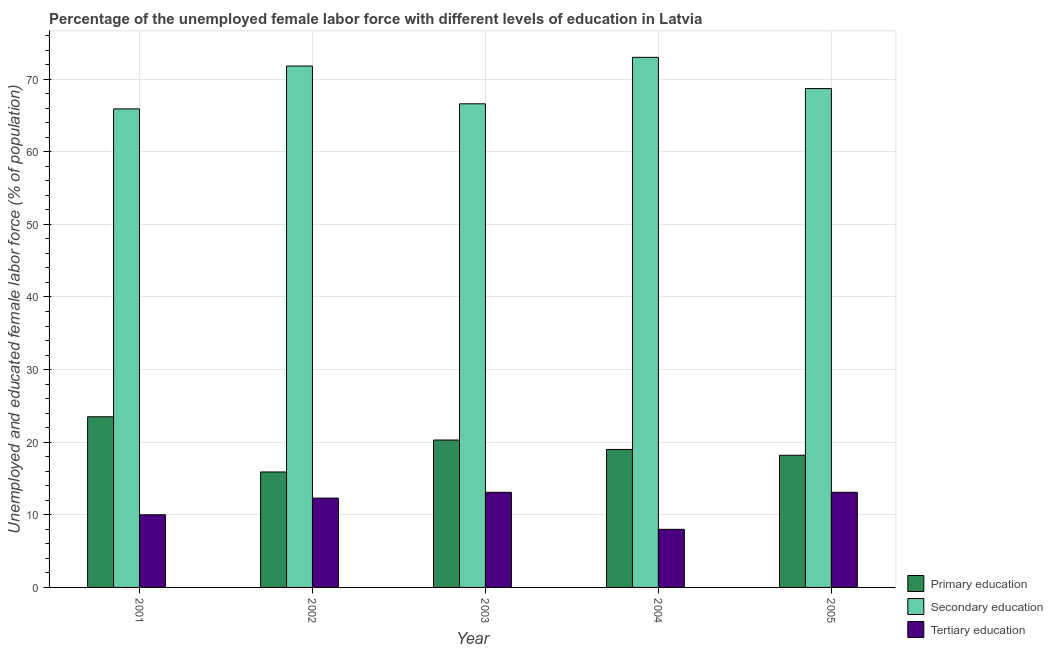How many different coloured bars are there?
Ensure brevity in your answer.  3. Are the number of bars on each tick of the X-axis equal?
Your answer should be compact. Yes. How many bars are there on the 2nd tick from the left?
Give a very brief answer. 3. How many bars are there on the 5th tick from the right?
Your answer should be very brief. 3. What is the percentage of female labor force who received tertiary education in 2001?
Give a very brief answer. 10. Across all years, what is the maximum percentage of female labor force who received primary education?
Offer a very short reply. 23.5. Across all years, what is the minimum percentage of female labor force who received secondary education?
Provide a short and direct response. 65.9. In which year was the percentage of female labor force who received tertiary education minimum?
Offer a terse response. 2004. What is the total percentage of female labor force who received primary education in the graph?
Make the answer very short. 96.9. What is the difference between the percentage of female labor force who received primary education in 2003 and that in 2004?
Provide a short and direct response. 1.3. What is the difference between the percentage of female labor force who received primary education in 2001 and the percentage of female labor force who received tertiary education in 2004?
Your answer should be compact. 4.5. What is the average percentage of female labor force who received tertiary education per year?
Provide a short and direct response. 11.3. In how many years, is the percentage of female labor force who received primary education greater than 54 %?
Ensure brevity in your answer.  0. What is the ratio of the percentage of female labor force who received tertiary education in 2003 to that in 2004?
Offer a very short reply. 1.64. Is the percentage of female labor force who received primary education in 2001 less than that in 2003?
Provide a succinct answer. No. Is the difference between the percentage of female labor force who received primary education in 2001 and 2005 greater than the difference between the percentage of female labor force who received secondary education in 2001 and 2005?
Give a very brief answer. No. What is the difference between the highest and the second highest percentage of female labor force who received primary education?
Give a very brief answer. 3.2. What is the difference between the highest and the lowest percentage of female labor force who received secondary education?
Your answer should be very brief. 7.1. Is the sum of the percentage of female labor force who received primary education in 2001 and 2003 greater than the maximum percentage of female labor force who received tertiary education across all years?
Offer a terse response. Yes. What does the 3rd bar from the left in 2003 represents?
Provide a short and direct response. Tertiary education. What does the 1st bar from the right in 2003 represents?
Your answer should be very brief. Tertiary education. Is it the case that in every year, the sum of the percentage of female labor force who received primary education and percentage of female labor force who received secondary education is greater than the percentage of female labor force who received tertiary education?
Give a very brief answer. Yes. How many bars are there?
Ensure brevity in your answer.  15. Are all the bars in the graph horizontal?
Your answer should be very brief. No. Are the values on the major ticks of Y-axis written in scientific E-notation?
Make the answer very short. No. Does the graph contain grids?
Ensure brevity in your answer.  Yes. Where does the legend appear in the graph?
Your answer should be compact. Bottom right. How many legend labels are there?
Your response must be concise. 3. What is the title of the graph?
Make the answer very short. Percentage of the unemployed female labor force with different levels of education in Latvia. Does "Ores and metals" appear as one of the legend labels in the graph?
Provide a short and direct response. No. What is the label or title of the Y-axis?
Make the answer very short. Unemployed and educated female labor force (% of population). What is the Unemployed and educated female labor force (% of population) in Primary education in 2001?
Your response must be concise. 23.5. What is the Unemployed and educated female labor force (% of population) in Secondary education in 2001?
Offer a terse response. 65.9. What is the Unemployed and educated female labor force (% of population) of Tertiary education in 2001?
Make the answer very short. 10. What is the Unemployed and educated female labor force (% of population) in Primary education in 2002?
Make the answer very short. 15.9. What is the Unemployed and educated female labor force (% of population) in Secondary education in 2002?
Offer a terse response. 71.8. What is the Unemployed and educated female labor force (% of population) in Tertiary education in 2002?
Give a very brief answer. 12.3. What is the Unemployed and educated female labor force (% of population) in Primary education in 2003?
Offer a very short reply. 20.3. What is the Unemployed and educated female labor force (% of population) in Secondary education in 2003?
Provide a short and direct response. 66.6. What is the Unemployed and educated female labor force (% of population) of Tertiary education in 2003?
Provide a short and direct response. 13.1. What is the Unemployed and educated female labor force (% of population) in Primary education in 2004?
Make the answer very short. 19. What is the Unemployed and educated female labor force (% of population) of Primary education in 2005?
Provide a succinct answer. 18.2. What is the Unemployed and educated female labor force (% of population) in Secondary education in 2005?
Ensure brevity in your answer.  68.7. What is the Unemployed and educated female labor force (% of population) in Tertiary education in 2005?
Offer a very short reply. 13.1. Across all years, what is the maximum Unemployed and educated female labor force (% of population) in Secondary education?
Make the answer very short. 73. Across all years, what is the maximum Unemployed and educated female labor force (% of population) of Tertiary education?
Ensure brevity in your answer.  13.1. Across all years, what is the minimum Unemployed and educated female labor force (% of population) of Primary education?
Ensure brevity in your answer.  15.9. Across all years, what is the minimum Unemployed and educated female labor force (% of population) in Secondary education?
Make the answer very short. 65.9. What is the total Unemployed and educated female labor force (% of population) of Primary education in the graph?
Provide a short and direct response. 96.9. What is the total Unemployed and educated female labor force (% of population) of Secondary education in the graph?
Offer a very short reply. 346. What is the total Unemployed and educated female labor force (% of population) in Tertiary education in the graph?
Keep it short and to the point. 56.5. What is the difference between the Unemployed and educated female labor force (% of population) of Primary education in 2001 and that in 2002?
Your answer should be compact. 7.6. What is the difference between the Unemployed and educated female labor force (% of population) in Primary education in 2001 and that in 2003?
Provide a succinct answer. 3.2. What is the difference between the Unemployed and educated female labor force (% of population) of Secondary education in 2001 and that in 2003?
Your answer should be compact. -0.7. What is the difference between the Unemployed and educated female labor force (% of population) in Tertiary education in 2001 and that in 2003?
Provide a succinct answer. -3.1. What is the difference between the Unemployed and educated female labor force (% of population) of Primary education in 2001 and that in 2004?
Provide a succinct answer. 4.5. What is the difference between the Unemployed and educated female labor force (% of population) of Secondary education in 2001 and that in 2004?
Offer a terse response. -7.1. What is the difference between the Unemployed and educated female labor force (% of population) in Tertiary education in 2001 and that in 2004?
Offer a very short reply. 2. What is the difference between the Unemployed and educated female labor force (% of population) in Secondary education in 2001 and that in 2005?
Keep it short and to the point. -2.8. What is the difference between the Unemployed and educated female labor force (% of population) in Primary education in 2002 and that in 2004?
Your response must be concise. -3.1. What is the difference between the Unemployed and educated female labor force (% of population) in Secondary education in 2002 and that in 2004?
Your response must be concise. -1.2. What is the difference between the Unemployed and educated female labor force (% of population) in Tertiary education in 2002 and that in 2004?
Give a very brief answer. 4.3. What is the difference between the Unemployed and educated female labor force (% of population) of Primary education in 2002 and that in 2005?
Your answer should be compact. -2.3. What is the difference between the Unemployed and educated female labor force (% of population) in Secondary education in 2002 and that in 2005?
Keep it short and to the point. 3.1. What is the difference between the Unemployed and educated female labor force (% of population) of Primary education in 2003 and that in 2004?
Make the answer very short. 1.3. What is the difference between the Unemployed and educated female labor force (% of population) in Secondary education in 2003 and that in 2004?
Your answer should be very brief. -6.4. What is the difference between the Unemployed and educated female labor force (% of population) in Primary education in 2003 and that in 2005?
Provide a short and direct response. 2.1. What is the difference between the Unemployed and educated female labor force (% of population) of Secondary education in 2003 and that in 2005?
Offer a very short reply. -2.1. What is the difference between the Unemployed and educated female labor force (% of population) in Tertiary education in 2003 and that in 2005?
Offer a terse response. 0. What is the difference between the Unemployed and educated female labor force (% of population) of Primary education in 2004 and that in 2005?
Your response must be concise. 0.8. What is the difference between the Unemployed and educated female labor force (% of population) of Secondary education in 2004 and that in 2005?
Give a very brief answer. 4.3. What is the difference between the Unemployed and educated female labor force (% of population) in Tertiary education in 2004 and that in 2005?
Make the answer very short. -5.1. What is the difference between the Unemployed and educated female labor force (% of population) of Primary education in 2001 and the Unemployed and educated female labor force (% of population) of Secondary education in 2002?
Your response must be concise. -48.3. What is the difference between the Unemployed and educated female labor force (% of population) of Secondary education in 2001 and the Unemployed and educated female labor force (% of population) of Tertiary education in 2002?
Offer a terse response. 53.6. What is the difference between the Unemployed and educated female labor force (% of population) in Primary education in 2001 and the Unemployed and educated female labor force (% of population) in Secondary education in 2003?
Make the answer very short. -43.1. What is the difference between the Unemployed and educated female labor force (% of population) in Secondary education in 2001 and the Unemployed and educated female labor force (% of population) in Tertiary education in 2003?
Keep it short and to the point. 52.8. What is the difference between the Unemployed and educated female labor force (% of population) of Primary education in 2001 and the Unemployed and educated female labor force (% of population) of Secondary education in 2004?
Offer a very short reply. -49.5. What is the difference between the Unemployed and educated female labor force (% of population) in Secondary education in 2001 and the Unemployed and educated female labor force (% of population) in Tertiary education in 2004?
Offer a terse response. 57.9. What is the difference between the Unemployed and educated female labor force (% of population) of Primary education in 2001 and the Unemployed and educated female labor force (% of population) of Secondary education in 2005?
Provide a short and direct response. -45.2. What is the difference between the Unemployed and educated female labor force (% of population) in Secondary education in 2001 and the Unemployed and educated female labor force (% of population) in Tertiary education in 2005?
Offer a very short reply. 52.8. What is the difference between the Unemployed and educated female labor force (% of population) of Primary education in 2002 and the Unemployed and educated female labor force (% of population) of Secondary education in 2003?
Give a very brief answer. -50.7. What is the difference between the Unemployed and educated female labor force (% of population) of Primary education in 2002 and the Unemployed and educated female labor force (% of population) of Tertiary education in 2003?
Give a very brief answer. 2.8. What is the difference between the Unemployed and educated female labor force (% of population) of Secondary education in 2002 and the Unemployed and educated female labor force (% of population) of Tertiary education in 2003?
Your answer should be very brief. 58.7. What is the difference between the Unemployed and educated female labor force (% of population) of Primary education in 2002 and the Unemployed and educated female labor force (% of population) of Secondary education in 2004?
Keep it short and to the point. -57.1. What is the difference between the Unemployed and educated female labor force (% of population) of Secondary education in 2002 and the Unemployed and educated female labor force (% of population) of Tertiary education in 2004?
Give a very brief answer. 63.8. What is the difference between the Unemployed and educated female labor force (% of population) of Primary education in 2002 and the Unemployed and educated female labor force (% of population) of Secondary education in 2005?
Make the answer very short. -52.8. What is the difference between the Unemployed and educated female labor force (% of population) in Primary education in 2002 and the Unemployed and educated female labor force (% of population) in Tertiary education in 2005?
Your response must be concise. 2.8. What is the difference between the Unemployed and educated female labor force (% of population) of Secondary education in 2002 and the Unemployed and educated female labor force (% of population) of Tertiary education in 2005?
Ensure brevity in your answer.  58.7. What is the difference between the Unemployed and educated female labor force (% of population) of Primary education in 2003 and the Unemployed and educated female labor force (% of population) of Secondary education in 2004?
Offer a very short reply. -52.7. What is the difference between the Unemployed and educated female labor force (% of population) of Secondary education in 2003 and the Unemployed and educated female labor force (% of population) of Tertiary education in 2004?
Offer a very short reply. 58.6. What is the difference between the Unemployed and educated female labor force (% of population) of Primary education in 2003 and the Unemployed and educated female labor force (% of population) of Secondary education in 2005?
Make the answer very short. -48.4. What is the difference between the Unemployed and educated female labor force (% of population) of Secondary education in 2003 and the Unemployed and educated female labor force (% of population) of Tertiary education in 2005?
Ensure brevity in your answer.  53.5. What is the difference between the Unemployed and educated female labor force (% of population) in Primary education in 2004 and the Unemployed and educated female labor force (% of population) in Secondary education in 2005?
Make the answer very short. -49.7. What is the difference between the Unemployed and educated female labor force (% of population) in Primary education in 2004 and the Unemployed and educated female labor force (% of population) in Tertiary education in 2005?
Give a very brief answer. 5.9. What is the difference between the Unemployed and educated female labor force (% of population) in Secondary education in 2004 and the Unemployed and educated female labor force (% of population) in Tertiary education in 2005?
Make the answer very short. 59.9. What is the average Unemployed and educated female labor force (% of population) in Primary education per year?
Offer a terse response. 19.38. What is the average Unemployed and educated female labor force (% of population) in Secondary education per year?
Keep it short and to the point. 69.2. What is the average Unemployed and educated female labor force (% of population) of Tertiary education per year?
Provide a short and direct response. 11.3. In the year 2001, what is the difference between the Unemployed and educated female labor force (% of population) in Primary education and Unemployed and educated female labor force (% of population) in Secondary education?
Your response must be concise. -42.4. In the year 2001, what is the difference between the Unemployed and educated female labor force (% of population) of Primary education and Unemployed and educated female labor force (% of population) of Tertiary education?
Keep it short and to the point. 13.5. In the year 2001, what is the difference between the Unemployed and educated female labor force (% of population) in Secondary education and Unemployed and educated female labor force (% of population) in Tertiary education?
Offer a very short reply. 55.9. In the year 2002, what is the difference between the Unemployed and educated female labor force (% of population) of Primary education and Unemployed and educated female labor force (% of population) of Secondary education?
Give a very brief answer. -55.9. In the year 2002, what is the difference between the Unemployed and educated female labor force (% of population) of Secondary education and Unemployed and educated female labor force (% of population) of Tertiary education?
Keep it short and to the point. 59.5. In the year 2003, what is the difference between the Unemployed and educated female labor force (% of population) of Primary education and Unemployed and educated female labor force (% of population) of Secondary education?
Offer a terse response. -46.3. In the year 2003, what is the difference between the Unemployed and educated female labor force (% of population) of Secondary education and Unemployed and educated female labor force (% of population) of Tertiary education?
Make the answer very short. 53.5. In the year 2004, what is the difference between the Unemployed and educated female labor force (% of population) in Primary education and Unemployed and educated female labor force (% of population) in Secondary education?
Ensure brevity in your answer.  -54. In the year 2004, what is the difference between the Unemployed and educated female labor force (% of population) in Primary education and Unemployed and educated female labor force (% of population) in Tertiary education?
Your response must be concise. 11. In the year 2004, what is the difference between the Unemployed and educated female labor force (% of population) in Secondary education and Unemployed and educated female labor force (% of population) in Tertiary education?
Offer a terse response. 65. In the year 2005, what is the difference between the Unemployed and educated female labor force (% of population) in Primary education and Unemployed and educated female labor force (% of population) in Secondary education?
Offer a very short reply. -50.5. In the year 2005, what is the difference between the Unemployed and educated female labor force (% of population) of Primary education and Unemployed and educated female labor force (% of population) of Tertiary education?
Keep it short and to the point. 5.1. In the year 2005, what is the difference between the Unemployed and educated female labor force (% of population) in Secondary education and Unemployed and educated female labor force (% of population) in Tertiary education?
Your answer should be very brief. 55.6. What is the ratio of the Unemployed and educated female labor force (% of population) in Primary education in 2001 to that in 2002?
Make the answer very short. 1.48. What is the ratio of the Unemployed and educated female labor force (% of population) of Secondary education in 2001 to that in 2002?
Your answer should be very brief. 0.92. What is the ratio of the Unemployed and educated female labor force (% of population) in Tertiary education in 2001 to that in 2002?
Provide a succinct answer. 0.81. What is the ratio of the Unemployed and educated female labor force (% of population) of Primary education in 2001 to that in 2003?
Your answer should be very brief. 1.16. What is the ratio of the Unemployed and educated female labor force (% of population) in Tertiary education in 2001 to that in 2003?
Offer a very short reply. 0.76. What is the ratio of the Unemployed and educated female labor force (% of population) of Primary education in 2001 to that in 2004?
Your answer should be compact. 1.24. What is the ratio of the Unemployed and educated female labor force (% of population) in Secondary education in 2001 to that in 2004?
Your answer should be very brief. 0.9. What is the ratio of the Unemployed and educated female labor force (% of population) in Tertiary education in 2001 to that in 2004?
Offer a terse response. 1.25. What is the ratio of the Unemployed and educated female labor force (% of population) in Primary education in 2001 to that in 2005?
Your answer should be very brief. 1.29. What is the ratio of the Unemployed and educated female labor force (% of population) of Secondary education in 2001 to that in 2005?
Your answer should be compact. 0.96. What is the ratio of the Unemployed and educated female labor force (% of population) in Tertiary education in 2001 to that in 2005?
Make the answer very short. 0.76. What is the ratio of the Unemployed and educated female labor force (% of population) of Primary education in 2002 to that in 2003?
Keep it short and to the point. 0.78. What is the ratio of the Unemployed and educated female labor force (% of population) in Secondary education in 2002 to that in 2003?
Ensure brevity in your answer.  1.08. What is the ratio of the Unemployed and educated female labor force (% of population) in Tertiary education in 2002 to that in 2003?
Provide a succinct answer. 0.94. What is the ratio of the Unemployed and educated female labor force (% of population) in Primary education in 2002 to that in 2004?
Keep it short and to the point. 0.84. What is the ratio of the Unemployed and educated female labor force (% of population) of Secondary education in 2002 to that in 2004?
Offer a very short reply. 0.98. What is the ratio of the Unemployed and educated female labor force (% of population) of Tertiary education in 2002 to that in 2004?
Give a very brief answer. 1.54. What is the ratio of the Unemployed and educated female labor force (% of population) of Primary education in 2002 to that in 2005?
Offer a terse response. 0.87. What is the ratio of the Unemployed and educated female labor force (% of population) of Secondary education in 2002 to that in 2005?
Provide a short and direct response. 1.05. What is the ratio of the Unemployed and educated female labor force (% of population) in Tertiary education in 2002 to that in 2005?
Offer a terse response. 0.94. What is the ratio of the Unemployed and educated female labor force (% of population) of Primary education in 2003 to that in 2004?
Offer a very short reply. 1.07. What is the ratio of the Unemployed and educated female labor force (% of population) of Secondary education in 2003 to that in 2004?
Make the answer very short. 0.91. What is the ratio of the Unemployed and educated female labor force (% of population) in Tertiary education in 2003 to that in 2004?
Make the answer very short. 1.64. What is the ratio of the Unemployed and educated female labor force (% of population) in Primary education in 2003 to that in 2005?
Provide a succinct answer. 1.12. What is the ratio of the Unemployed and educated female labor force (% of population) of Secondary education in 2003 to that in 2005?
Keep it short and to the point. 0.97. What is the ratio of the Unemployed and educated female labor force (% of population) in Tertiary education in 2003 to that in 2005?
Ensure brevity in your answer.  1. What is the ratio of the Unemployed and educated female labor force (% of population) of Primary education in 2004 to that in 2005?
Ensure brevity in your answer.  1.04. What is the ratio of the Unemployed and educated female labor force (% of population) in Secondary education in 2004 to that in 2005?
Make the answer very short. 1.06. What is the ratio of the Unemployed and educated female labor force (% of population) of Tertiary education in 2004 to that in 2005?
Provide a short and direct response. 0.61. What is the difference between the highest and the second highest Unemployed and educated female labor force (% of population) in Tertiary education?
Ensure brevity in your answer.  0. What is the difference between the highest and the lowest Unemployed and educated female labor force (% of population) in Secondary education?
Your answer should be very brief. 7.1. 